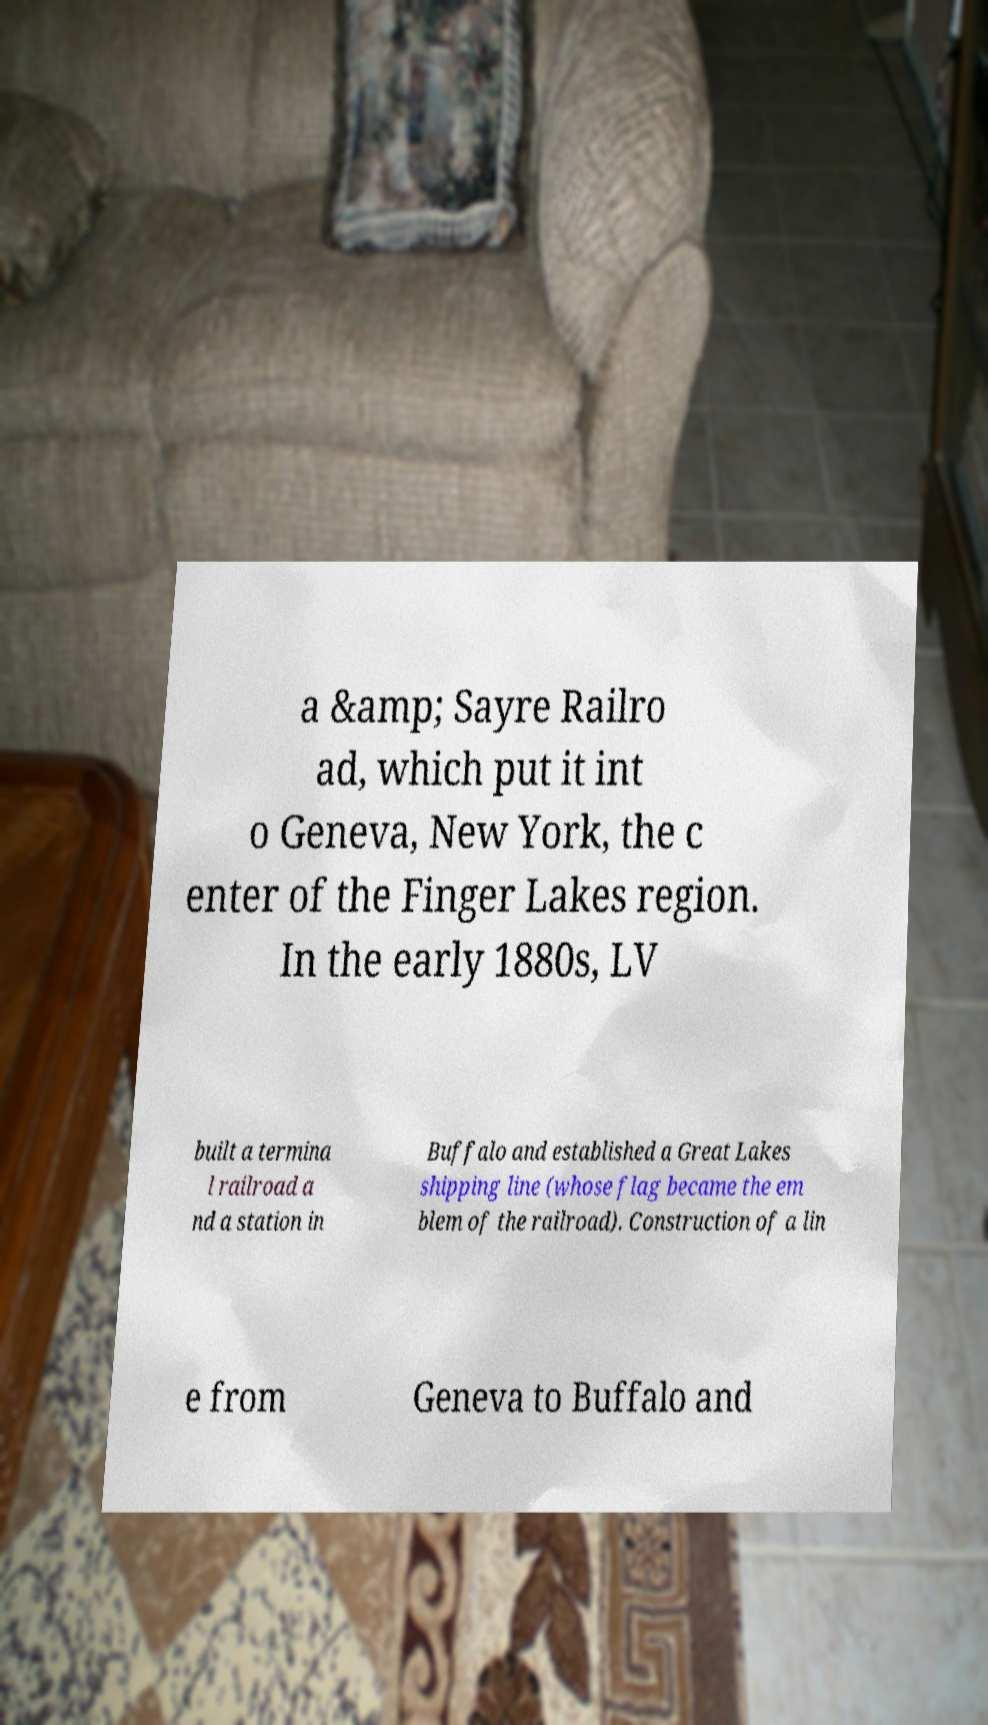Can you accurately transcribe the text from the provided image for me? a &amp; Sayre Railro ad, which put it int o Geneva, New York, the c enter of the Finger Lakes region. In the early 1880s, LV built a termina l railroad a nd a station in Buffalo and established a Great Lakes shipping line (whose flag became the em blem of the railroad). Construction of a lin e from Geneva to Buffalo and 